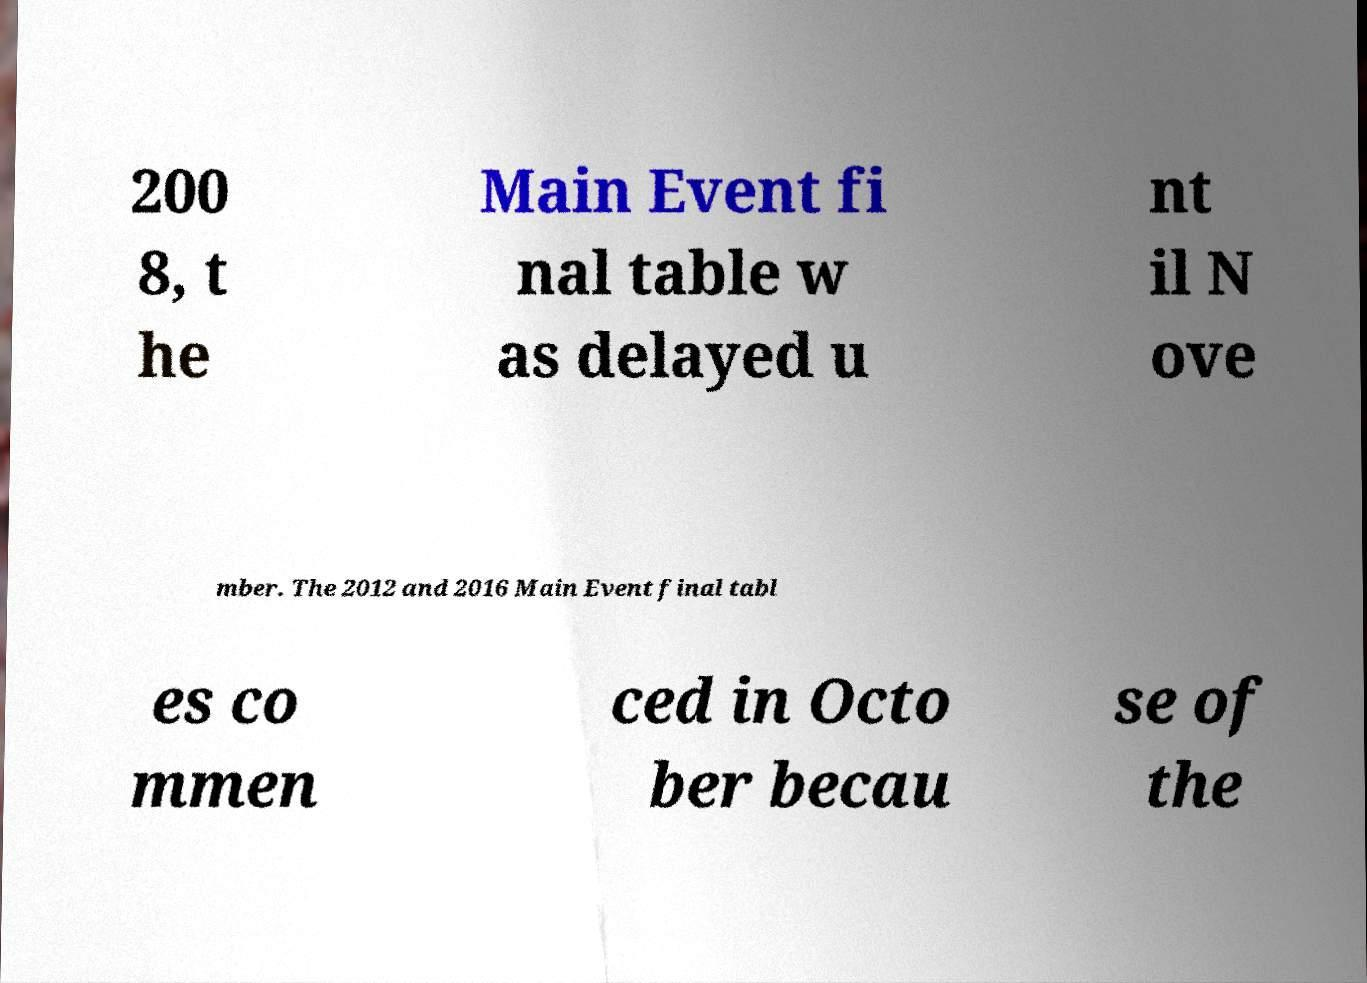What messages or text are displayed in this image? I need them in a readable, typed format. 200 8, t he Main Event fi nal table w as delayed u nt il N ove mber. The 2012 and 2016 Main Event final tabl es co mmen ced in Octo ber becau se of the 